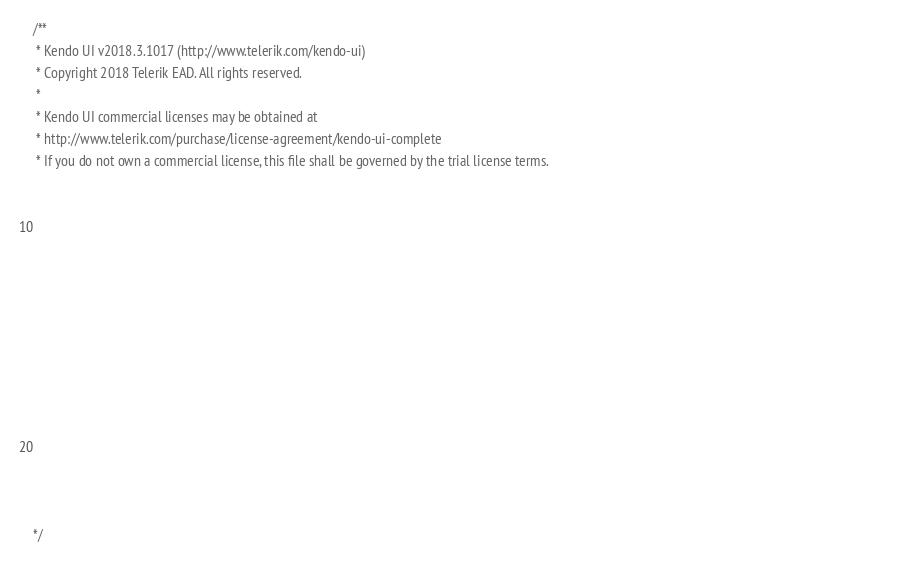Convert code to text. <code><loc_0><loc_0><loc_500><loc_500><_JavaScript_>/** 
 * Kendo UI v2018.3.1017 (http://www.telerik.com/kendo-ui)                                                                                                                                              
 * Copyright 2018 Telerik EAD. All rights reserved.                                                                                                                                                     
 *                                                                                                                                                                                                      
 * Kendo UI commercial licenses may be obtained at                                                                                                                                                      
 * http://www.telerik.com/purchase/license-agreement/kendo-ui-complete                                                                                                                                  
 * If you do not own a commercial license, this file shall be governed by the trial license terms.                                                                                                      
                                                                                                                                                                                                       
                                                                                                                                                                                                       
                                                                                                                                                                                                       
                                                                                                                                                                                                       
                                                                                                                                                                                                       
                                                                                                                                                                                                       
                                                                                                                                                                                                       
                                                                                                                                                                                                       
                                                                                                                                                                                                       
                                                                                                                                                                                                       
                                                                                                                                                                                                       
                                                                                                                                                                                                       
                                                                                                                                                                                                       
                                                                                                                                                                                                       
                                                                                                                                                                                                       

*/</code> 